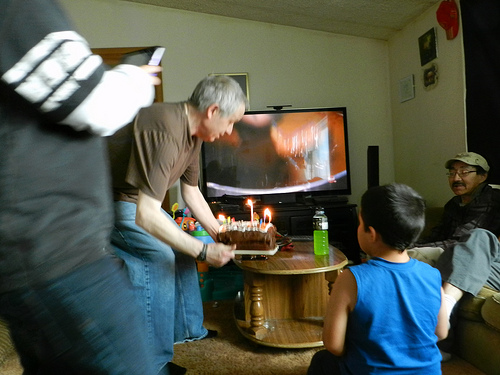What activities can you infer are taking place in this room, based on the image? There is a social gathering occurring, likely involving family or friends. A birthday cake with lit candles is ready for the person of honor to make a wish. It appears to be a casual and intimate setting with a focus on the birthday celebration. Can you describe what the person standing up is doing? The person standing up is likely the focus of the celebration, positioned to blow out the candles on the cake. He's leaning slightly forward, poised to extinguish the candles, which is a traditional part of a birthday party. 